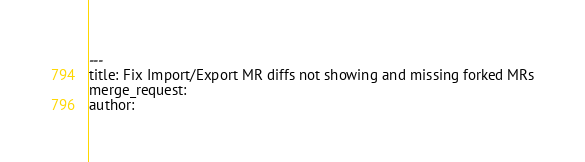<code> <loc_0><loc_0><loc_500><loc_500><_YAML_>---
title: Fix Import/Export MR diffs not showing and missing forked MRs
merge_request:
author:
</code> 